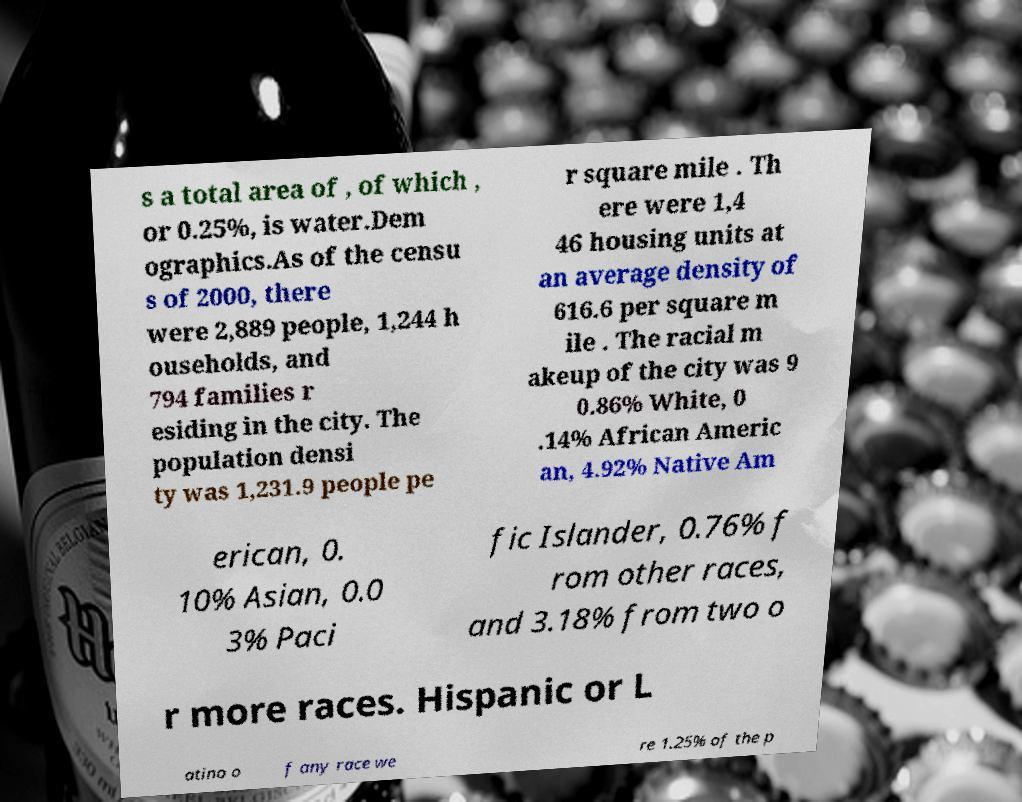Please identify and transcribe the text found in this image. s a total area of , of which , or 0.25%, is water.Dem ographics.As of the censu s of 2000, there were 2,889 people, 1,244 h ouseholds, and 794 families r esiding in the city. The population densi ty was 1,231.9 people pe r square mile . Th ere were 1,4 46 housing units at an average density of 616.6 per square m ile . The racial m akeup of the city was 9 0.86% White, 0 .14% African Americ an, 4.92% Native Am erican, 0. 10% Asian, 0.0 3% Paci fic Islander, 0.76% f rom other races, and 3.18% from two o r more races. Hispanic or L atino o f any race we re 1.25% of the p 